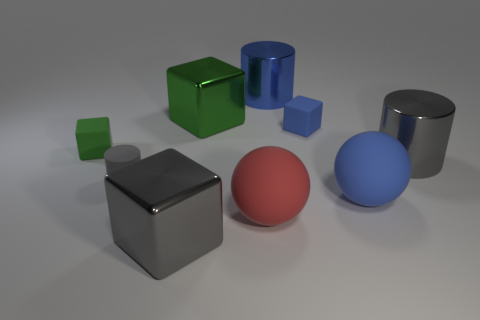Subtract 1 cylinders. How many cylinders are left? 2 Subtract all gray cubes. How many cubes are left? 3 Add 1 big green cubes. How many objects exist? 10 Subtract all purple cubes. Subtract all purple spheres. How many cubes are left? 4 Subtract all cylinders. How many objects are left? 6 Add 4 tiny blue matte cylinders. How many tiny blue matte cylinders exist? 4 Subtract 1 blue cubes. How many objects are left? 8 Subtract all green rubber things. Subtract all purple metal balls. How many objects are left? 8 Add 5 large metal things. How many large metal things are left? 9 